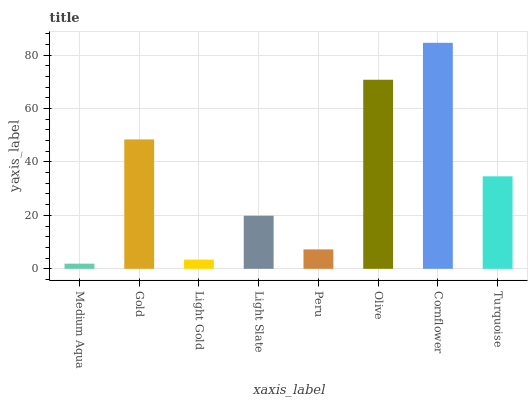Is Gold the minimum?
Answer yes or no. No. Is Gold the maximum?
Answer yes or no. No. Is Gold greater than Medium Aqua?
Answer yes or no. Yes. Is Medium Aqua less than Gold?
Answer yes or no. Yes. Is Medium Aqua greater than Gold?
Answer yes or no. No. Is Gold less than Medium Aqua?
Answer yes or no. No. Is Turquoise the high median?
Answer yes or no. Yes. Is Light Slate the low median?
Answer yes or no. Yes. Is Cornflower the high median?
Answer yes or no. No. Is Cornflower the low median?
Answer yes or no. No. 